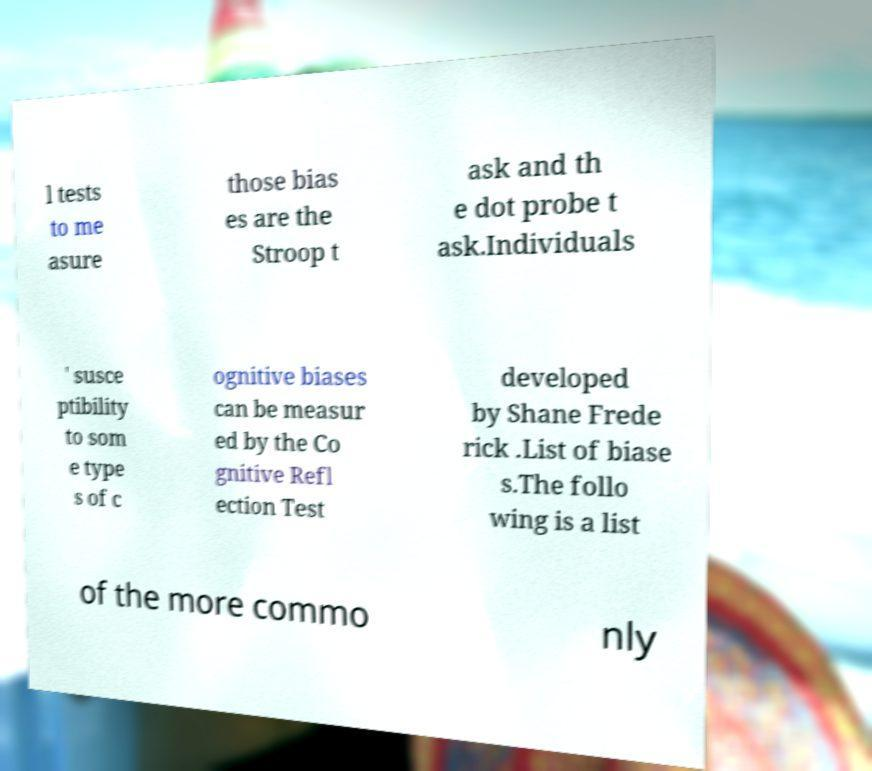Please read and relay the text visible in this image. What does it say? l tests to me asure those bias es are the Stroop t ask and th e dot probe t ask.Individuals ' susce ptibility to som e type s of c ognitive biases can be measur ed by the Co gnitive Refl ection Test developed by Shane Frede rick .List of biase s.The follo wing is a list of the more commo nly 